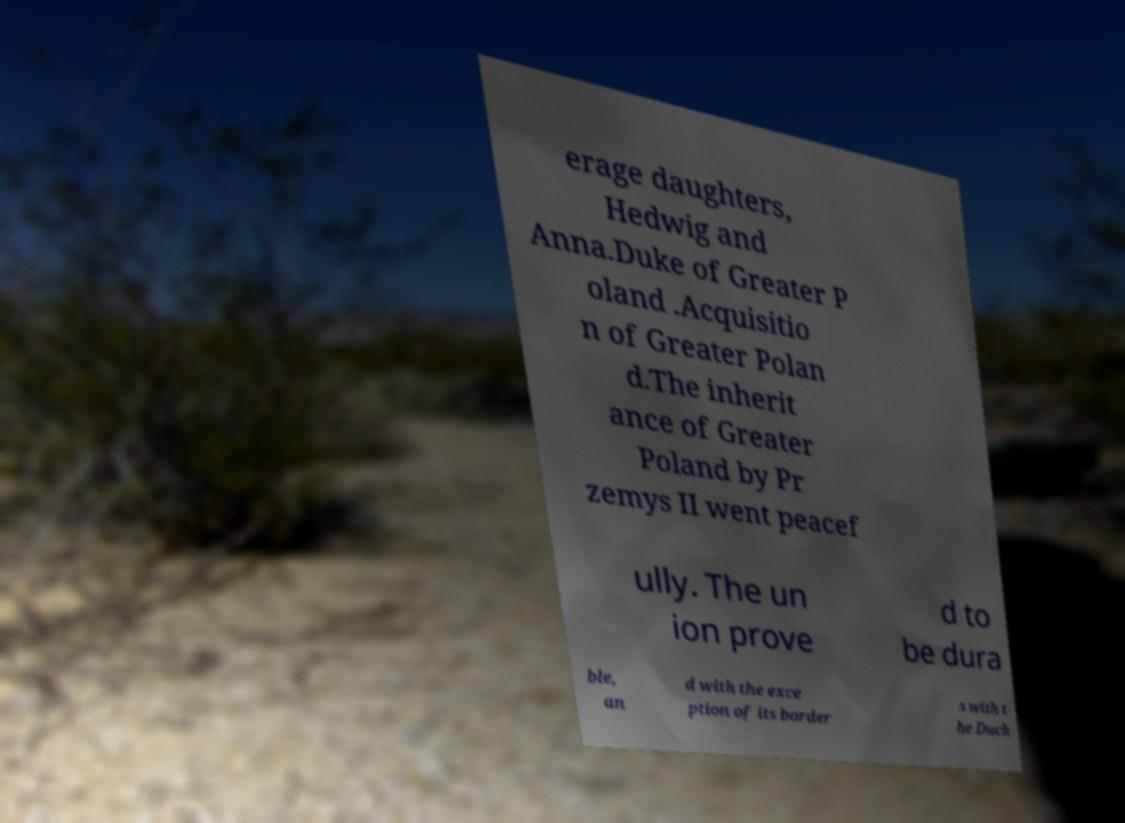There's text embedded in this image that I need extracted. Can you transcribe it verbatim? erage daughters, Hedwig and Anna.Duke of Greater P oland .Acquisitio n of Greater Polan d.The inherit ance of Greater Poland by Pr zemys II went peacef ully. The un ion prove d to be dura ble, an d with the exce ption of its border s with t he Duch 